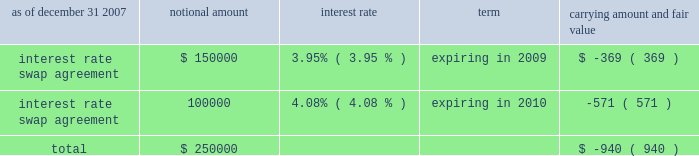American tower corporation and subsidiaries notes to consolidated financial statements 2014 ( continued ) market and lease the unused tower space on the broadcast towers ( the economic rights ) .
Tv azteca retains title to these towers and is responsible for their operation and maintenance .
The company is entitled to 100% ( 100 % ) of the revenues generated from leases with tenants on the unused space and is responsible for any incremental operating expenses associated with those tenants .
The term of the economic rights agreement is seventy years ; however , tv azteca has the right to purchase , at fair market value , the economic rights from the company at any time during the last fifty years of the agreement .
Should tv azteca elect to purchase the economic rights ( in whole or in part ) , it would also be obligated to repay a proportional amount of the loan discussed above at the time of such election .
The company 2019s obligation to pay tv azteca $ 1.5 million annually would also be reduced proportionally .
The company has accounted for the annual payment of $ 1.5 million as a capital lease ( initially recording an asset and a corresponding liability of approximately $ 18.6 million ) .
The capital lease asset and the discount on the note , which aggregate approximately $ 30.2 million , represent the cost to acquire the economic rights and are being amortized over the seventy-year life of the economic rights agreement .
On a quarterly basis , the company assesses the recoverability of its note receivable from tv azteca .
As of december 31 , 2007 and 2006 , the company has assessed the recoverability of the note receivable from tv azteca and concluded that no adjustment to its carrying value is required .
A former executive officer and former director of the company served as a director of tv azteca from december 1999 to february 2006 .
As of december 31 , 2007 and 2006 , the company also had other long-term notes receivable outstanding of approximately $ 4.3 million and $ 11.0 million , respectively .
Derivative financial instruments the company enters into interest rate protection agreements to manage exposure on the variable rate debt under its credit facilities and to manage variability in cash flows relating to forecasted interest payments .
Under these agreements , the company is exposed to credit risk to the extent that a counterparty fails to meet the terms of a contract .
Such exposure was limited to the current value of the contract at the time the counterparty fails to perform .
The company believes its contracts as of december 31 , 2007 and 2006 are with credit worthy institutions .
As of december 31 , 2007 and 2006 , the carrying amounts of the company 2019s derivative financial instruments , along with the estimated fair values of the related assets reflected in notes receivable and other long-term assets and ( liabilities ) reflected in other long-term liabilities in the accompanying consolidated balance sheet , are as follows ( in thousands except percentages ) : as of december 31 , 2007 notional amount interest rate term carrying amount and fair value .

What is the net change in the balance of other long-term notes receivable during 2007? 
Computations: (11.0 - 4.3)
Answer: 6.7. 